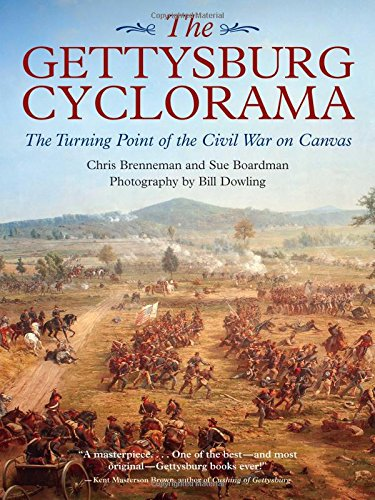Is this a reference book? No, this book is not a reference book. While it provides deep historical insights and detailed visual content, its primary aim is to narrate and visually present the events rather than serve as a purely informational reference guide. 